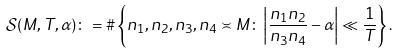Convert formula to latex. <formula><loc_0><loc_0><loc_500><loc_500>\mathcal { S } ( M , T , \alpha ) \colon = \# \left \{ n _ { 1 } , n _ { 2 } , n _ { 3 } , n _ { 4 } \asymp M \colon \left | \frac { n _ { 1 } n _ { 2 } } { n _ { 3 } n _ { 4 } } - \alpha \right | \ll \frac { 1 } { T } \right \} .</formula> 